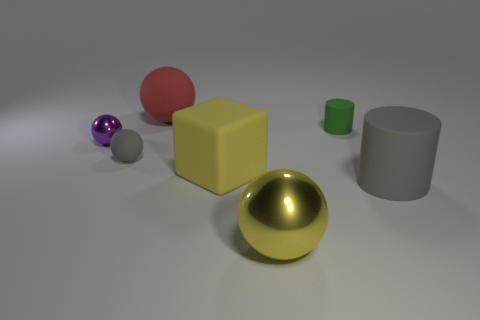Is the green thing made of the same material as the gray object to the right of the tiny gray sphere?
Your response must be concise. Yes. What is the shape of the large gray thing that is the same material as the small gray sphere?
Offer a very short reply. Cylinder. The metal sphere that is the same size as the green thing is what color?
Your answer should be very brief. Purple. There is a shiny sphere that is behind the yellow sphere; is it the same size as the yellow matte cube?
Give a very brief answer. No. Is the color of the big rubber block the same as the large shiny thing?
Provide a succinct answer. Yes. How many tiny purple metallic spheres are there?
Your response must be concise. 1. How many spheres are either large yellow rubber things or tiny things?
Offer a terse response. 2. There is a small metallic object behind the large yellow rubber object; how many big blocks are to the right of it?
Keep it short and to the point. 1. Are the big red object and the small purple ball made of the same material?
Ensure brevity in your answer.  No. There is a object that is the same color as the small rubber sphere; what is its size?
Provide a succinct answer. Large. 